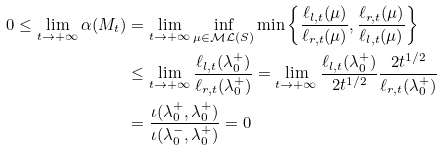<formula> <loc_0><loc_0><loc_500><loc_500>0 \leq \lim _ { t \to + \infty } \alpha ( M _ { t } ) & = \lim _ { t \to + \infty } \inf _ { \mu \in \mathcal { M L } ( S ) } \min \left \{ \frac { \ell _ { l , t } ( \mu ) } { \ell _ { r , t } ( \mu ) } , \frac { \ell _ { r , t } ( \mu ) } { \ell _ { l , t } ( \mu ) } \right \} \\ & \leq \lim _ { t \to + \infty } \frac { \ell _ { l , t } ( \lambda _ { 0 } ^ { + } ) } { \ell _ { r , t } ( \lambda _ { 0 } ^ { + } ) } = \lim _ { t \to + \infty } \frac { \ell _ { l , t } ( \lambda _ { 0 } ^ { + } ) } { 2 t ^ { 1 / 2 } } \frac { 2 t ^ { 1 / 2 } } { \ell _ { r , t } ( \lambda _ { 0 } ^ { + } ) } \\ & = \frac { \iota ( \lambda _ { 0 } ^ { + } , \lambda _ { 0 } ^ { + } ) } { \iota ( \lambda _ { 0 } ^ { - } , \lambda _ { 0 } ^ { + } ) } = 0</formula> 